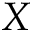Convert formula to latex. <formula><loc_0><loc_0><loc_500><loc_500>X</formula> 